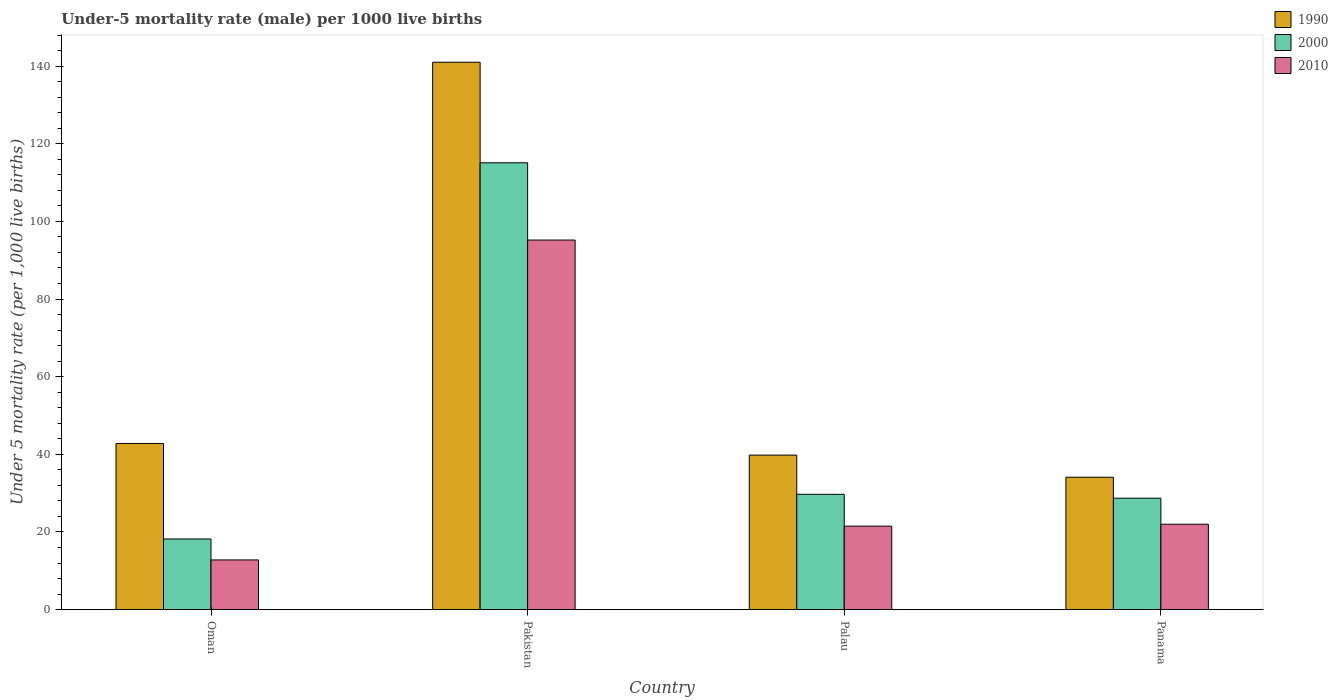What is the label of the 4th group of bars from the left?
Offer a very short reply. Panama. Across all countries, what is the maximum under-five mortality rate in 1990?
Ensure brevity in your answer.  141. Across all countries, what is the minimum under-five mortality rate in 1990?
Your response must be concise. 34.1. In which country was the under-five mortality rate in 2010 minimum?
Offer a terse response. Oman. What is the total under-five mortality rate in 2000 in the graph?
Provide a succinct answer. 191.7. What is the difference between the under-five mortality rate in 2000 in Oman and the under-five mortality rate in 2010 in Panama?
Offer a very short reply. -3.8. What is the average under-five mortality rate in 2010 per country?
Give a very brief answer. 37.88. What is the difference between the under-five mortality rate of/in 2010 and under-five mortality rate of/in 2000 in Oman?
Ensure brevity in your answer.  -5.4. In how many countries, is the under-five mortality rate in 2010 greater than 140?
Provide a short and direct response. 0. What is the ratio of the under-five mortality rate in 2000 in Oman to that in Panama?
Give a very brief answer. 0.63. Is the difference between the under-five mortality rate in 2010 in Pakistan and Panama greater than the difference between the under-five mortality rate in 2000 in Pakistan and Panama?
Provide a succinct answer. No. What is the difference between the highest and the second highest under-five mortality rate in 2010?
Your answer should be compact. -0.5. What is the difference between the highest and the lowest under-five mortality rate in 1990?
Ensure brevity in your answer.  106.9. In how many countries, is the under-five mortality rate in 1990 greater than the average under-five mortality rate in 1990 taken over all countries?
Provide a short and direct response. 1. What does the 1st bar from the right in Oman represents?
Offer a terse response. 2010. Is it the case that in every country, the sum of the under-five mortality rate in 1990 and under-five mortality rate in 2000 is greater than the under-five mortality rate in 2010?
Provide a succinct answer. Yes. Are all the bars in the graph horizontal?
Provide a short and direct response. No. What is the difference between two consecutive major ticks on the Y-axis?
Give a very brief answer. 20. Are the values on the major ticks of Y-axis written in scientific E-notation?
Your answer should be very brief. No. Does the graph contain any zero values?
Ensure brevity in your answer.  No. Where does the legend appear in the graph?
Offer a very short reply. Top right. How many legend labels are there?
Your response must be concise. 3. What is the title of the graph?
Offer a terse response. Under-5 mortality rate (male) per 1000 live births. Does "1986" appear as one of the legend labels in the graph?
Offer a terse response. No. What is the label or title of the Y-axis?
Your response must be concise. Under 5 mortality rate (per 1,0 live births). What is the Under 5 mortality rate (per 1,000 live births) of 1990 in Oman?
Offer a terse response. 42.8. What is the Under 5 mortality rate (per 1,000 live births) in 1990 in Pakistan?
Offer a terse response. 141. What is the Under 5 mortality rate (per 1,000 live births) of 2000 in Pakistan?
Give a very brief answer. 115.1. What is the Under 5 mortality rate (per 1,000 live births) in 2010 in Pakistan?
Provide a short and direct response. 95.2. What is the Under 5 mortality rate (per 1,000 live births) in 1990 in Palau?
Your answer should be very brief. 39.8. What is the Under 5 mortality rate (per 1,000 live births) of 2000 in Palau?
Offer a terse response. 29.7. What is the Under 5 mortality rate (per 1,000 live births) in 1990 in Panama?
Give a very brief answer. 34.1. What is the Under 5 mortality rate (per 1,000 live births) of 2000 in Panama?
Your answer should be compact. 28.7. Across all countries, what is the maximum Under 5 mortality rate (per 1,000 live births) in 1990?
Keep it short and to the point. 141. Across all countries, what is the maximum Under 5 mortality rate (per 1,000 live births) of 2000?
Make the answer very short. 115.1. Across all countries, what is the maximum Under 5 mortality rate (per 1,000 live births) of 2010?
Provide a succinct answer. 95.2. Across all countries, what is the minimum Under 5 mortality rate (per 1,000 live births) of 1990?
Offer a terse response. 34.1. Across all countries, what is the minimum Under 5 mortality rate (per 1,000 live births) in 2000?
Ensure brevity in your answer.  18.2. Across all countries, what is the minimum Under 5 mortality rate (per 1,000 live births) in 2010?
Give a very brief answer. 12.8. What is the total Under 5 mortality rate (per 1,000 live births) in 1990 in the graph?
Offer a very short reply. 257.7. What is the total Under 5 mortality rate (per 1,000 live births) of 2000 in the graph?
Provide a short and direct response. 191.7. What is the total Under 5 mortality rate (per 1,000 live births) of 2010 in the graph?
Offer a very short reply. 151.5. What is the difference between the Under 5 mortality rate (per 1,000 live births) in 1990 in Oman and that in Pakistan?
Your answer should be compact. -98.2. What is the difference between the Under 5 mortality rate (per 1,000 live births) of 2000 in Oman and that in Pakistan?
Provide a succinct answer. -96.9. What is the difference between the Under 5 mortality rate (per 1,000 live births) in 2010 in Oman and that in Pakistan?
Your answer should be very brief. -82.4. What is the difference between the Under 5 mortality rate (per 1,000 live births) in 1990 in Oman and that in Panama?
Offer a terse response. 8.7. What is the difference between the Under 5 mortality rate (per 1,000 live births) of 1990 in Pakistan and that in Palau?
Provide a short and direct response. 101.2. What is the difference between the Under 5 mortality rate (per 1,000 live births) in 2000 in Pakistan and that in Palau?
Your response must be concise. 85.4. What is the difference between the Under 5 mortality rate (per 1,000 live births) of 2010 in Pakistan and that in Palau?
Provide a succinct answer. 73.7. What is the difference between the Under 5 mortality rate (per 1,000 live births) of 1990 in Pakistan and that in Panama?
Offer a terse response. 106.9. What is the difference between the Under 5 mortality rate (per 1,000 live births) in 2000 in Pakistan and that in Panama?
Provide a short and direct response. 86.4. What is the difference between the Under 5 mortality rate (per 1,000 live births) of 2010 in Pakistan and that in Panama?
Provide a succinct answer. 73.2. What is the difference between the Under 5 mortality rate (per 1,000 live births) of 1990 in Palau and that in Panama?
Offer a very short reply. 5.7. What is the difference between the Under 5 mortality rate (per 1,000 live births) of 1990 in Oman and the Under 5 mortality rate (per 1,000 live births) of 2000 in Pakistan?
Provide a succinct answer. -72.3. What is the difference between the Under 5 mortality rate (per 1,000 live births) of 1990 in Oman and the Under 5 mortality rate (per 1,000 live births) of 2010 in Pakistan?
Your response must be concise. -52.4. What is the difference between the Under 5 mortality rate (per 1,000 live births) in 2000 in Oman and the Under 5 mortality rate (per 1,000 live births) in 2010 in Pakistan?
Give a very brief answer. -77. What is the difference between the Under 5 mortality rate (per 1,000 live births) in 1990 in Oman and the Under 5 mortality rate (per 1,000 live births) in 2000 in Palau?
Ensure brevity in your answer.  13.1. What is the difference between the Under 5 mortality rate (per 1,000 live births) in 1990 in Oman and the Under 5 mortality rate (per 1,000 live births) in 2010 in Palau?
Offer a terse response. 21.3. What is the difference between the Under 5 mortality rate (per 1,000 live births) of 1990 in Oman and the Under 5 mortality rate (per 1,000 live births) of 2000 in Panama?
Ensure brevity in your answer.  14.1. What is the difference between the Under 5 mortality rate (per 1,000 live births) in 1990 in Oman and the Under 5 mortality rate (per 1,000 live births) in 2010 in Panama?
Keep it short and to the point. 20.8. What is the difference between the Under 5 mortality rate (per 1,000 live births) in 1990 in Pakistan and the Under 5 mortality rate (per 1,000 live births) in 2000 in Palau?
Keep it short and to the point. 111.3. What is the difference between the Under 5 mortality rate (per 1,000 live births) of 1990 in Pakistan and the Under 5 mortality rate (per 1,000 live births) of 2010 in Palau?
Give a very brief answer. 119.5. What is the difference between the Under 5 mortality rate (per 1,000 live births) in 2000 in Pakistan and the Under 5 mortality rate (per 1,000 live births) in 2010 in Palau?
Offer a terse response. 93.6. What is the difference between the Under 5 mortality rate (per 1,000 live births) in 1990 in Pakistan and the Under 5 mortality rate (per 1,000 live births) in 2000 in Panama?
Keep it short and to the point. 112.3. What is the difference between the Under 5 mortality rate (per 1,000 live births) in 1990 in Pakistan and the Under 5 mortality rate (per 1,000 live births) in 2010 in Panama?
Offer a terse response. 119. What is the difference between the Under 5 mortality rate (per 1,000 live births) in 2000 in Pakistan and the Under 5 mortality rate (per 1,000 live births) in 2010 in Panama?
Ensure brevity in your answer.  93.1. What is the difference between the Under 5 mortality rate (per 1,000 live births) of 1990 in Palau and the Under 5 mortality rate (per 1,000 live births) of 2000 in Panama?
Your answer should be compact. 11.1. What is the difference between the Under 5 mortality rate (per 1,000 live births) of 1990 in Palau and the Under 5 mortality rate (per 1,000 live births) of 2010 in Panama?
Offer a terse response. 17.8. What is the difference between the Under 5 mortality rate (per 1,000 live births) of 2000 in Palau and the Under 5 mortality rate (per 1,000 live births) of 2010 in Panama?
Keep it short and to the point. 7.7. What is the average Under 5 mortality rate (per 1,000 live births) of 1990 per country?
Your answer should be compact. 64.42. What is the average Under 5 mortality rate (per 1,000 live births) of 2000 per country?
Ensure brevity in your answer.  47.92. What is the average Under 5 mortality rate (per 1,000 live births) of 2010 per country?
Your answer should be very brief. 37.88. What is the difference between the Under 5 mortality rate (per 1,000 live births) of 1990 and Under 5 mortality rate (per 1,000 live births) of 2000 in Oman?
Give a very brief answer. 24.6. What is the difference between the Under 5 mortality rate (per 1,000 live births) of 1990 and Under 5 mortality rate (per 1,000 live births) of 2010 in Oman?
Your answer should be very brief. 30. What is the difference between the Under 5 mortality rate (per 1,000 live births) in 2000 and Under 5 mortality rate (per 1,000 live births) in 2010 in Oman?
Ensure brevity in your answer.  5.4. What is the difference between the Under 5 mortality rate (per 1,000 live births) in 1990 and Under 5 mortality rate (per 1,000 live births) in 2000 in Pakistan?
Give a very brief answer. 25.9. What is the difference between the Under 5 mortality rate (per 1,000 live births) of 1990 and Under 5 mortality rate (per 1,000 live births) of 2010 in Pakistan?
Offer a terse response. 45.8. What is the difference between the Under 5 mortality rate (per 1,000 live births) of 2000 and Under 5 mortality rate (per 1,000 live births) of 2010 in Pakistan?
Ensure brevity in your answer.  19.9. What is the difference between the Under 5 mortality rate (per 1,000 live births) in 1990 and Under 5 mortality rate (per 1,000 live births) in 2010 in Palau?
Offer a terse response. 18.3. What is the difference between the Under 5 mortality rate (per 1,000 live births) in 1990 and Under 5 mortality rate (per 1,000 live births) in 2010 in Panama?
Offer a terse response. 12.1. What is the difference between the Under 5 mortality rate (per 1,000 live births) of 2000 and Under 5 mortality rate (per 1,000 live births) of 2010 in Panama?
Your response must be concise. 6.7. What is the ratio of the Under 5 mortality rate (per 1,000 live births) of 1990 in Oman to that in Pakistan?
Ensure brevity in your answer.  0.3. What is the ratio of the Under 5 mortality rate (per 1,000 live births) in 2000 in Oman to that in Pakistan?
Make the answer very short. 0.16. What is the ratio of the Under 5 mortality rate (per 1,000 live births) of 2010 in Oman to that in Pakistan?
Offer a terse response. 0.13. What is the ratio of the Under 5 mortality rate (per 1,000 live births) in 1990 in Oman to that in Palau?
Your answer should be very brief. 1.08. What is the ratio of the Under 5 mortality rate (per 1,000 live births) of 2000 in Oman to that in Palau?
Your response must be concise. 0.61. What is the ratio of the Under 5 mortality rate (per 1,000 live births) of 2010 in Oman to that in Palau?
Give a very brief answer. 0.6. What is the ratio of the Under 5 mortality rate (per 1,000 live births) in 1990 in Oman to that in Panama?
Provide a succinct answer. 1.26. What is the ratio of the Under 5 mortality rate (per 1,000 live births) in 2000 in Oman to that in Panama?
Offer a very short reply. 0.63. What is the ratio of the Under 5 mortality rate (per 1,000 live births) of 2010 in Oman to that in Panama?
Ensure brevity in your answer.  0.58. What is the ratio of the Under 5 mortality rate (per 1,000 live births) in 1990 in Pakistan to that in Palau?
Provide a succinct answer. 3.54. What is the ratio of the Under 5 mortality rate (per 1,000 live births) of 2000 in Pakistan to that in Palau?
Offer a terse response. 3.88. What is the ratio of the Under 5 mortality rate (per 1,000 live births) of 2010 in Pakistan to that in Palau?
Ensure brevity in your answer.  4.43. What is the ratio of the Under 5 mortality rate (per 1,000 live births) of 1990 in Pakistan to that in Panama?
Ensure brevity in your answer.  4.13. What is the ratio of the Under 5 mortality rate (per 1,000 live births) of 2000 in Pakistan to that in Panama?
Make the answer very short. 4.01. What is the ratio of the Under 5 mortality rate (per 1,000 live births) in 2010 in Pakistan to that in Panama?
Provide a succinct answer. 4.33. What is the ratio of the Under 5 mortality rate (per 1,000 live births) in 1990 in Palau to that in Panama?
Ensure brevity in your answer.  1.17. What is the ratio of the Under 5 mortality rate (per 1,000 live births) in 2000 in Palau to that in Panama?
Give a very brief answer. 1.03. What is the ratio of the Under 5 mortality rate (per 1,000 live births) in 2010 in Palau to that in Panama?
Provide a succinct answer. 0.98. What is the difference between the highest and the second highest Under 5 mortality rate (per 1,000 live births) of 1990?
Your answer should be compact. 98.2. What is the difference between the highest and the second highest Under 5 mortality rate (per 1,000 live births) of 2000?
Provide a succinct answer. 85.4. What is the difference between the highest and the second highest Under 5 mortality rate (per 1,000 live births) in 2010?
Your response must be concise. 73.2. What is the difference between the highest and the lowest Under 5 mortality rate (per 1,000 live births) of 1990?
Provide a succinct answer. 106.9. What is the difference between the highest and the lowest Under 5 mortality rate (per 1,000 live births) in 2000?
Give a very brief answer. 96.9. What is the difference between the highest and the lowest Under 5 mortality rate (per 1,000 live births) in 2010?
Make the answer very short. 82.4. 